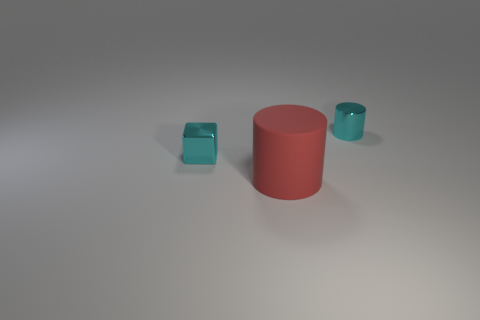Add 1 tiny green rubber cylinders. How many objects exist? 4 Subtract all red cylinders. How many cylinders are left? 1 Add 2 blue rubber objects. How many blue rubber objects exist? 2 Subtract 0 gray cylinders. How many objects are left? 3 Subtract all cubes. How many objects are left? 2 Subtract 1 blocks. How many blocks are left? 0 Subtract all green blocks. Subtract all brown cylinders. How many blocks are left? 1 Subtract all cyan spheres. How many blue cylinders are left? 0 Subtract all big brown metal balls. Subtract all large red cylinders. How many objects are left? 2 Add 3 metallic blocks. How many metallic blocks are left? 4 